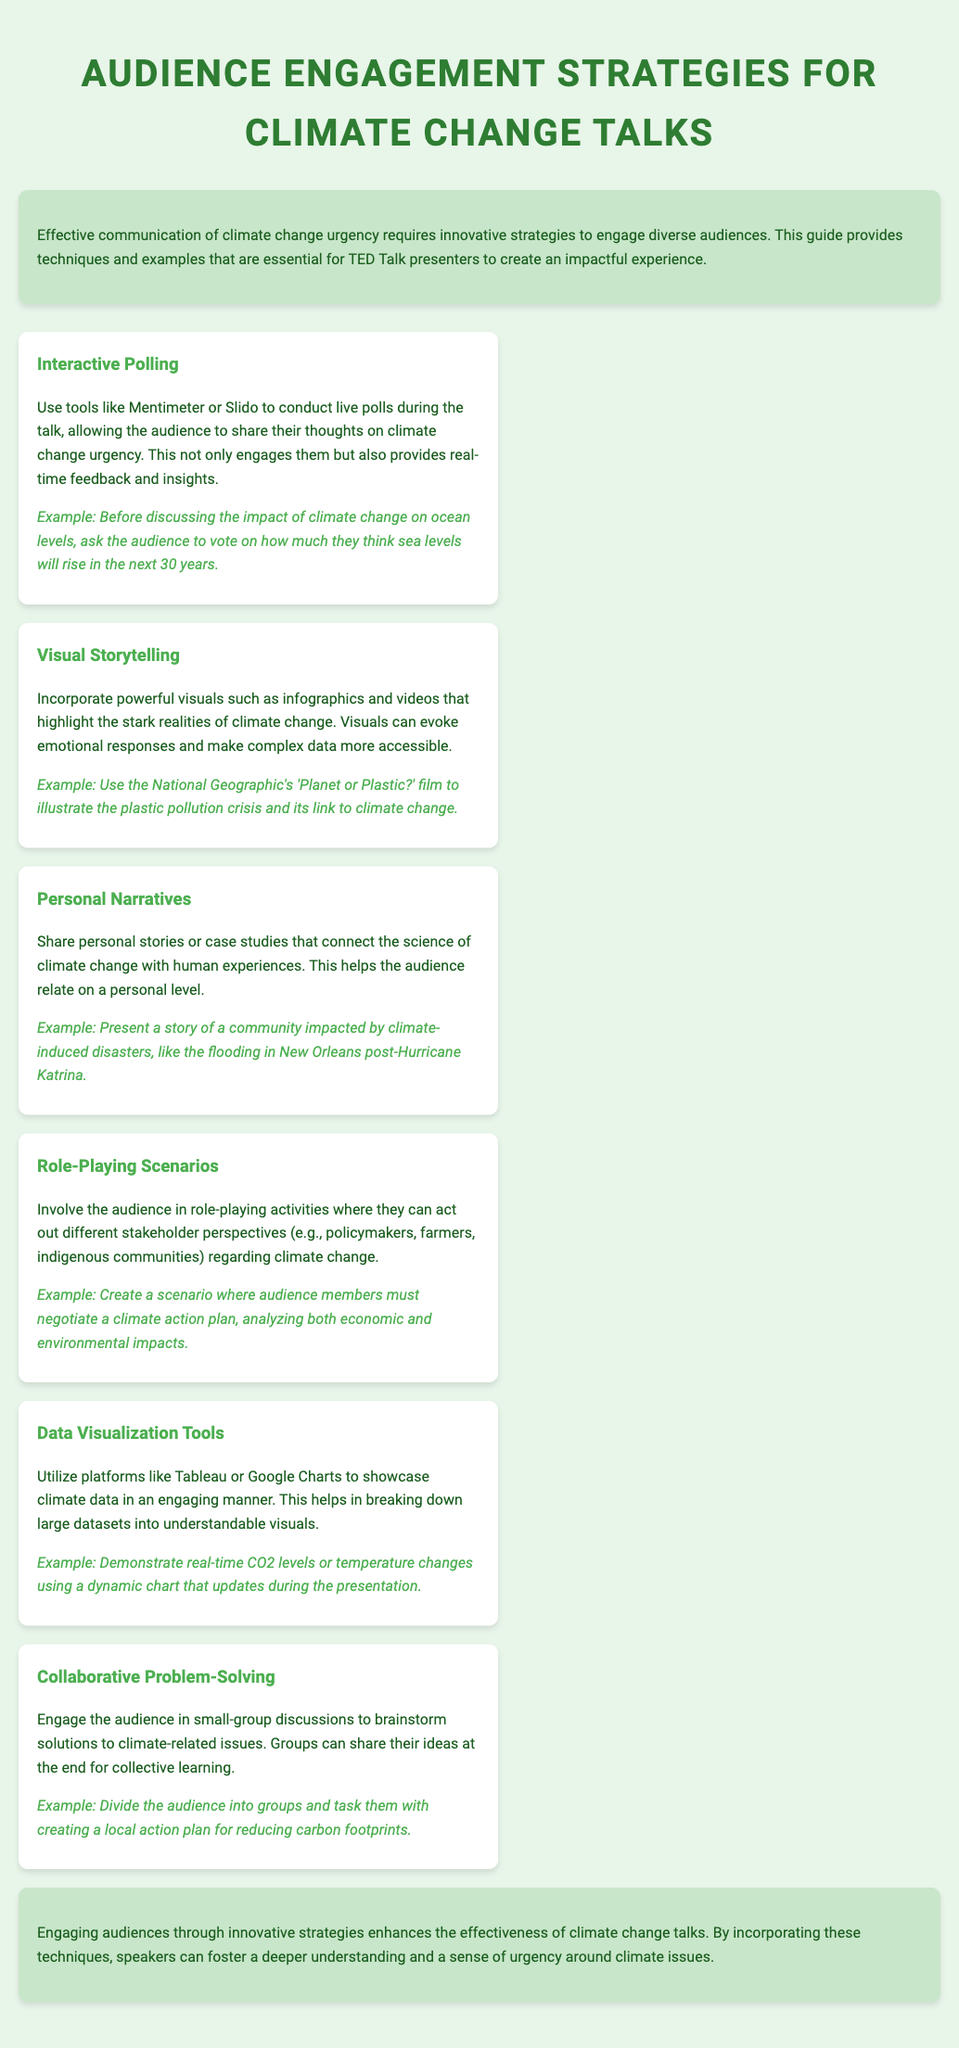What is the title of the document? The title introduces the main subject of the document which is audience engagement strategies for climate change talks.
Answer: Audience Engagement Strategies for Climate Change Talks What is one tool suggested for interactive polling? The document lists tools that can be used for live polls during the talk to engage the audience.
Answer: Mentimeter Name a visual storytelling example mentioned in the document. The document provides a specific film that can be used to illustrate climate-related issues.
Answer: Planet or Plastic? What is the purpose of role-playing scenarios in the document? The document describes how role-playing activities can engage the audience and allow them to explore different perspectives on climate change.
Answer: Involve the audience Which climate change impact is highlighted in the personal narratives strategy? The document gives an example of a community affected by a climate-induced disaster to create a relatable narrative.
Answer: Flooding in New Orleans What type of discussions does collaborative problem-solving involve? The document emphasizes the importance of small-group discussions among the audience to come up with solutions to climate issues.
Answer: Group discussions How does the document suggest showcasing climate data? The ways to present vast climate data visually in an engaging manner are discussed in the document.
Answer: Data Visualization Tools What color is used for the background of the document? The background color is specified in the document's style section, which sets the tone for the visual design.
Answer: Light green (E8F5E9) 